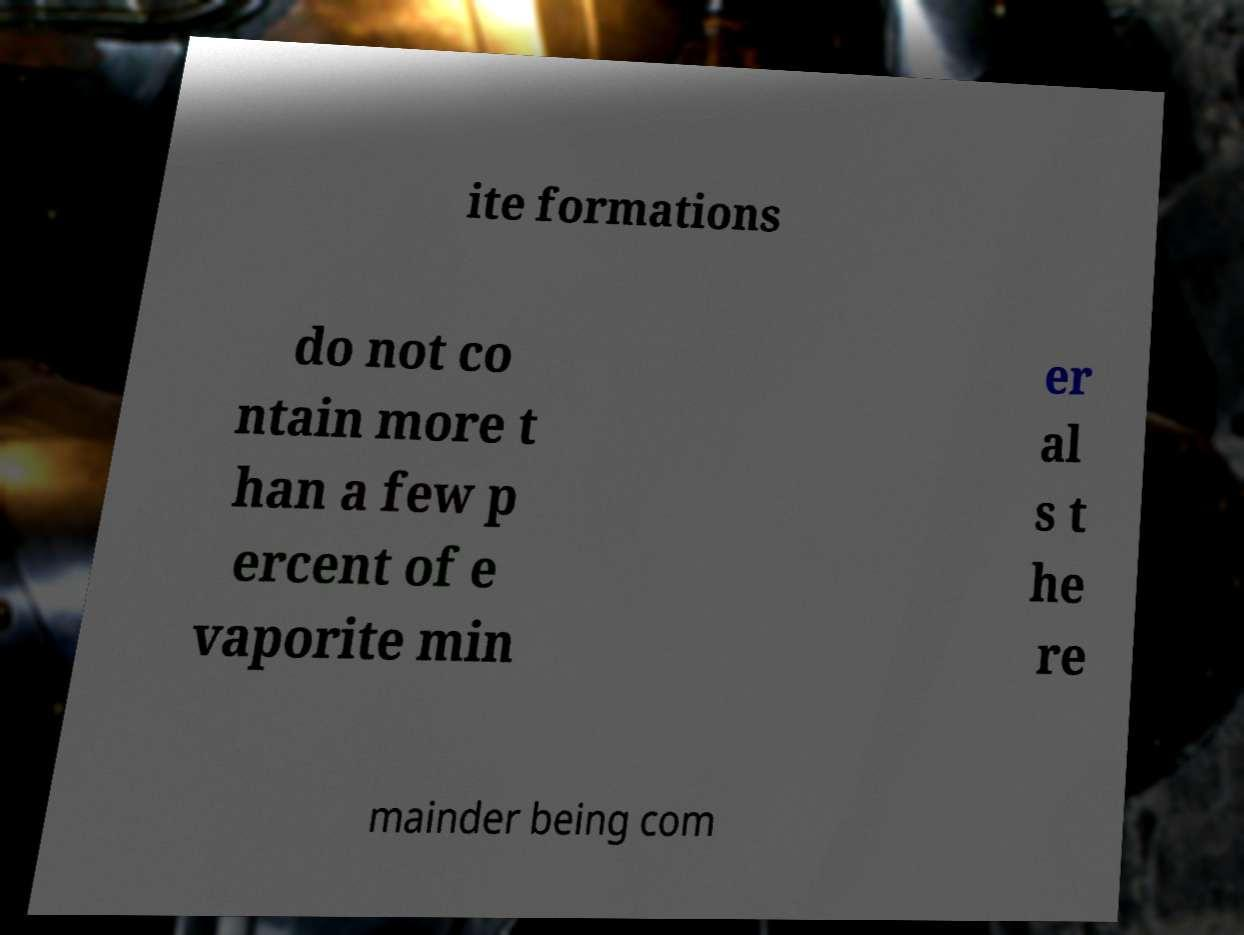There's text embedded in this image that I need extracted. Can you transcribe it verbatim? ite formations do not co ntain more t han a few p ercent of e vaporite min er al s t he re mainder being com 